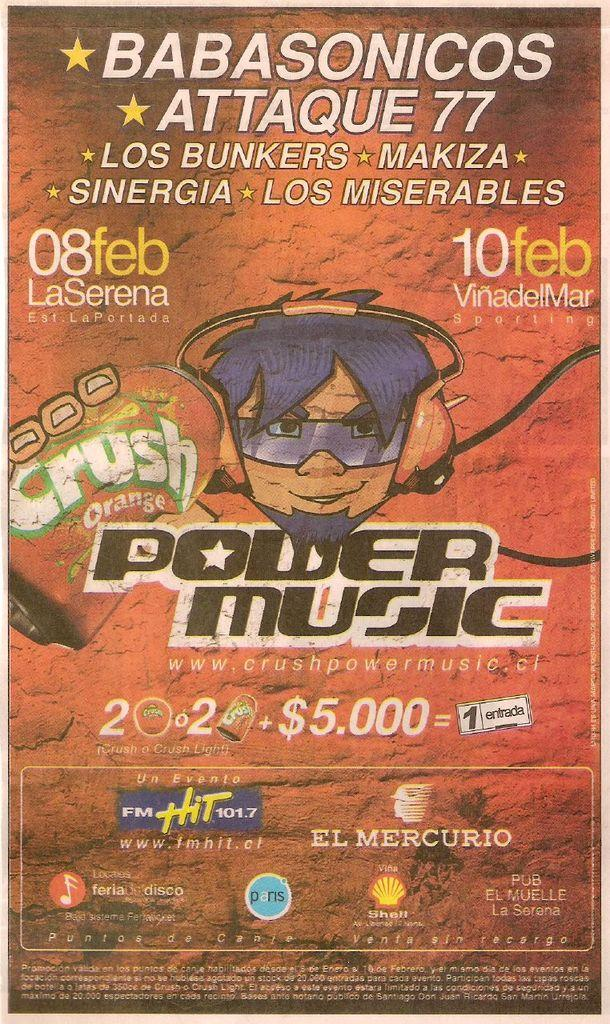<image>
Give a short and clear explanation of the subsequent image. An advertisement from Power Music is doing something involving Crush orange soda. 